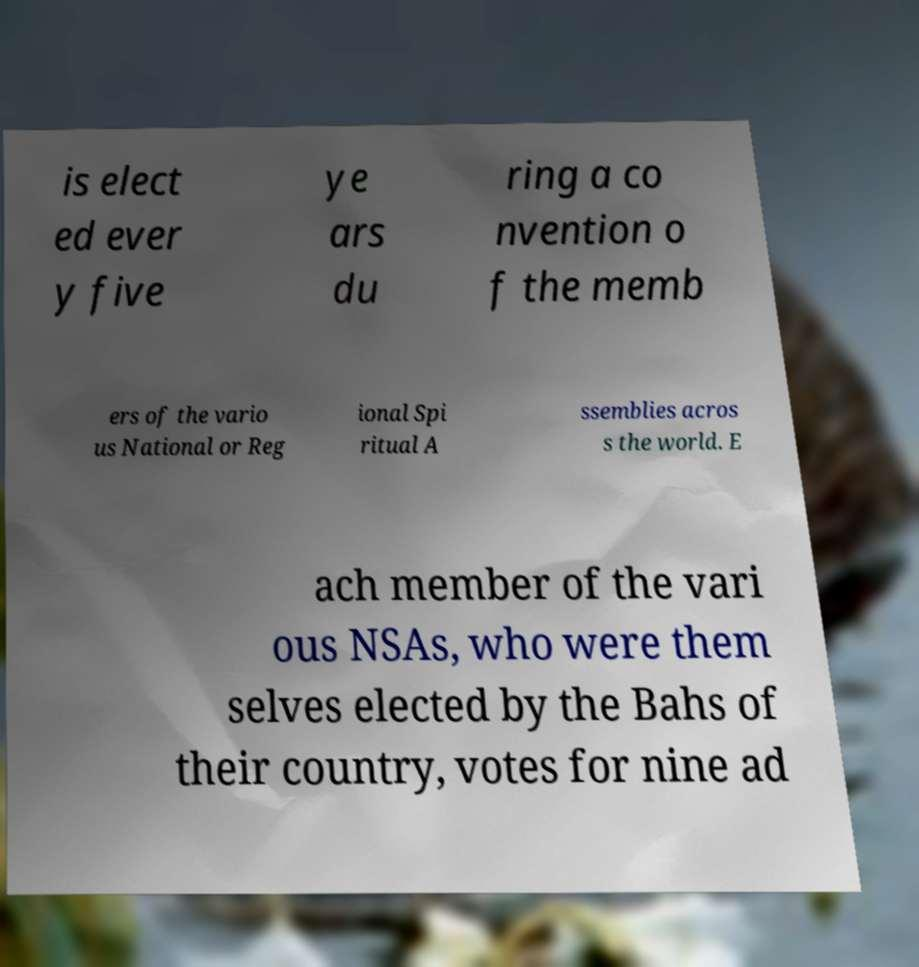I need the written content from this picture converted into text. Can you do that? is elect ed ever y five ye ars du ring a co nvention o f the memb ers of the vario us National or Reg ional Spi ritual A ssemblies acros s the world. E ach member of the vari ous NSAs, who were them selves elected by the Bahs of their country, votes for nine ad 